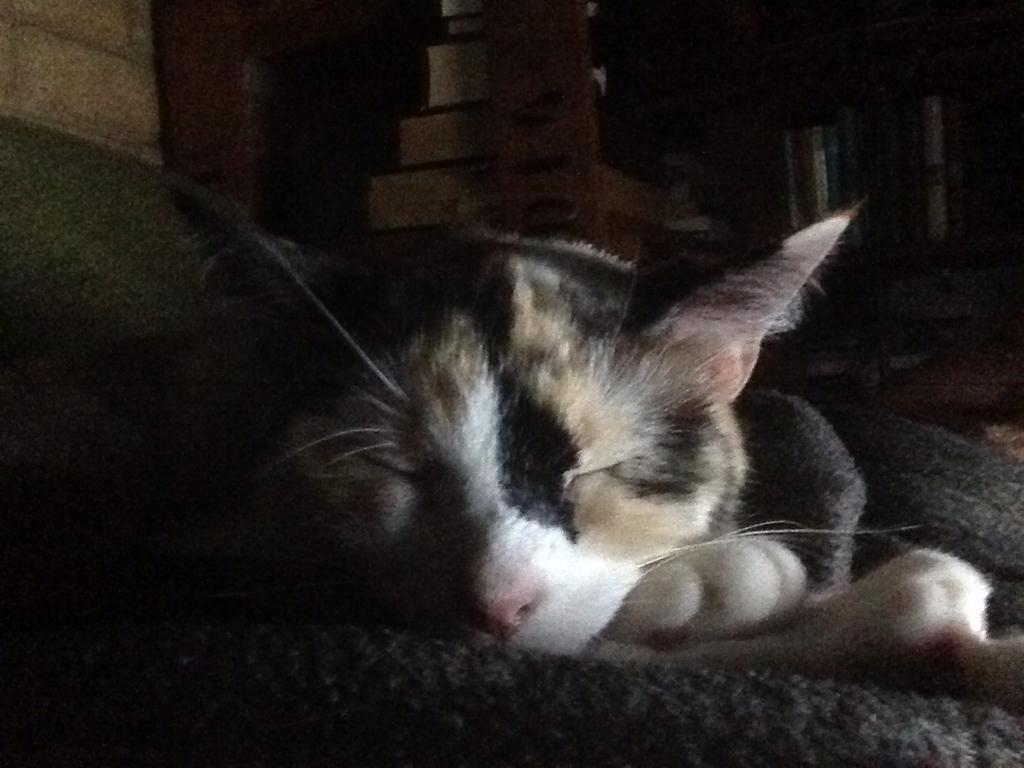What animal can be seen in the image? There is a cat in the image. What is the cat doing in the image? The cat is laying on a mat. What can be observed about the background of the image? The background of the image is dark. What type of story is being told at the playground in the image? There is no playground or storytelling present in the image; it features a cat laying on a mat with a dark background. 